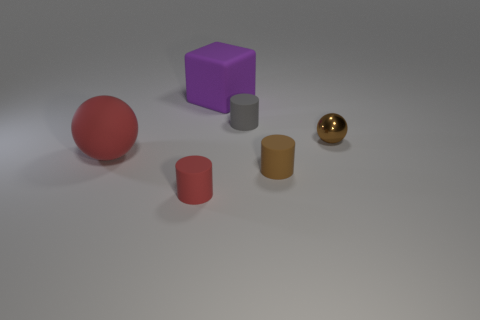What number of objects are small rubber cylinders that are to the right of the red cylinder or red objects that are in front of the large red rubber thing?
Give a very brief answer. 3. Is the size of the cube the same as the red matte cylinder?
Your answer should be compact. No. There is a red thing that is in front of the red matte ball; is its shape the same as the brown thing in front of the small sphere?
Provide a short and direct response. Yes. How big is the red sphere?
Your answer should be very brief. Large. The small thing to the left of the cylinder behind the ball that is to the left of the big cube is made of what material?
Offer a terse response. Rubber. How many other objects are the same color as the metal thing?
Your answer should be compact. 1. What number of cyan objects are blocks or spheres?
Provide a succinct answer. 0. What material is the ball that is right of the big purple rubber cube?
Keep it short and to the point. Metal. Is the material of the big thing to the right of the big red ball the same as the small sphere?
Your response must be concise. No. What shape is the large red rubber thing?
Provide a succinct answer. Sphere. 